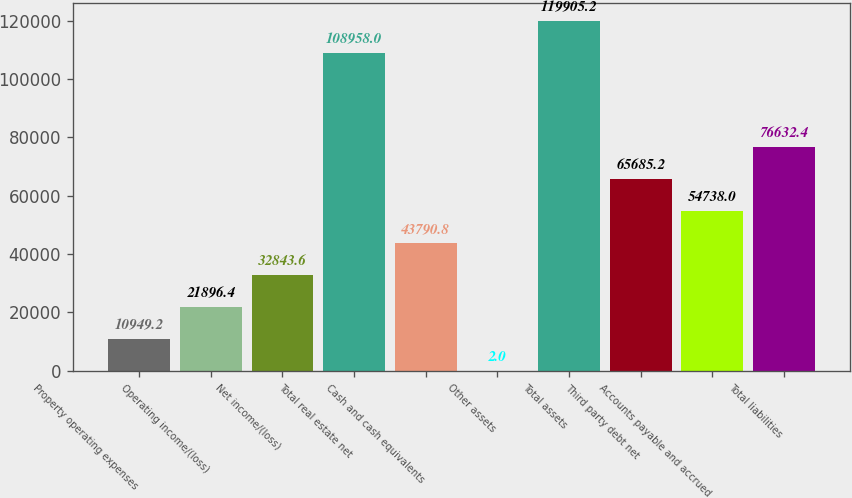Convert chart to OTSL. <chart><loc_0><loc_0><loc_500><loc_500><bar_chart><fcel>Property operating expenses<fcel>Operating income/(loss)<fcel>Net income/(loss)<fcel>Total real estate net<fcel>Cash and cash equivalents<fcel>Other assets<fcel>Total assets<fcel>Third party debt net<fcel>Accounts payable and accrued<fcel>Total liabilities<nl><fcel>10949.2<fcel>21896.4<fcel>32843.6<fcel>108958<fcel>43790.8<fcel>2<fcel>119905<fcel>65685.2<fcel>54738<fcel>76632.4<nl></chart> 